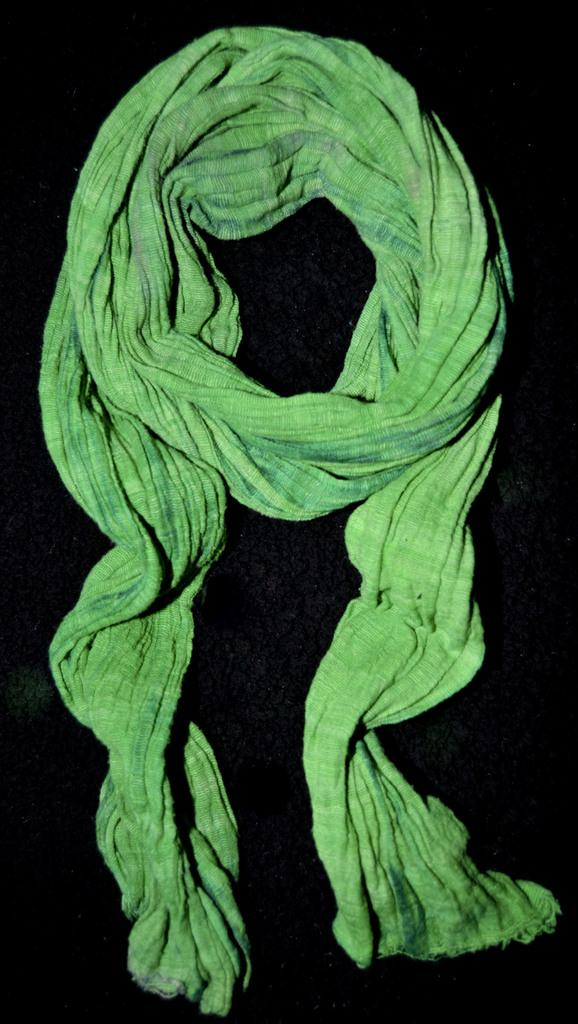What color is the cloth that is visible in the image? The cloth in the image is green. What is the color of the surface on which the green cloth is placed? The surface is black. What type of hall can be seen in the image? There is no hall present in the image; it only features a green cloth placed on a black surface. What substance is being poured from the tank in the image? There is no tank or substance present in the image. 